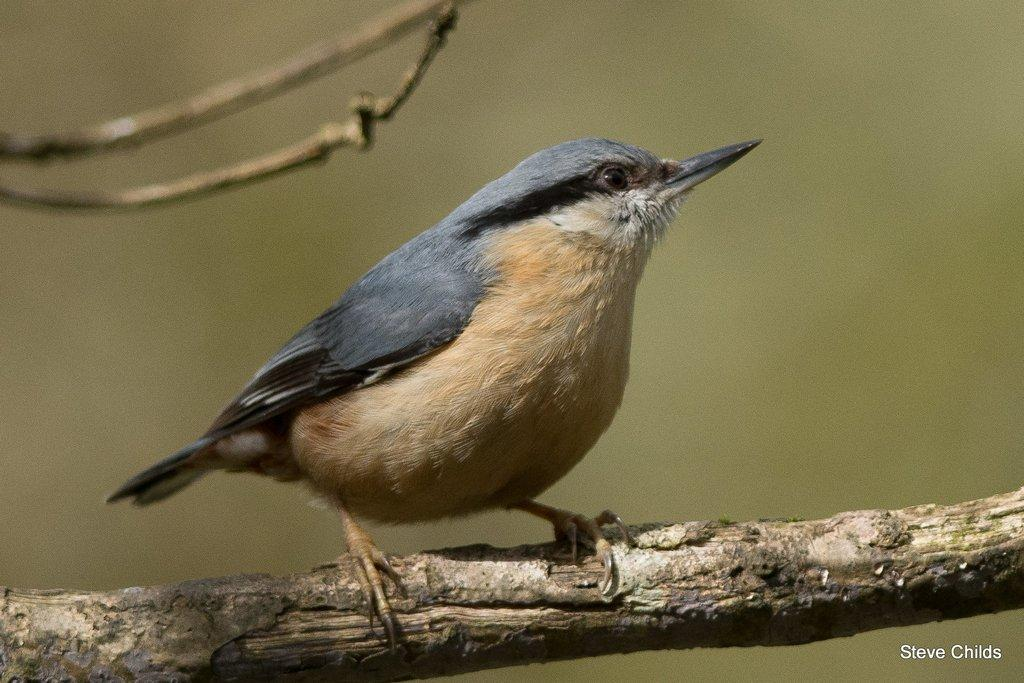What type of animal is present in the image? There is a bird in the image. Where is the bird located in the image? The bird is on a stem in the image. Is there any additional information or markings in the image? Yes, there is a watermark in the right bottom corner of the image. What type of drain can be seen in the image? There is no drain present in the image; it features a bird on a stem and a watermark. What day of the week is depicted in the image? The image does not depict a specific day of the week; it only shows a bird, a stem, and a watermark. 